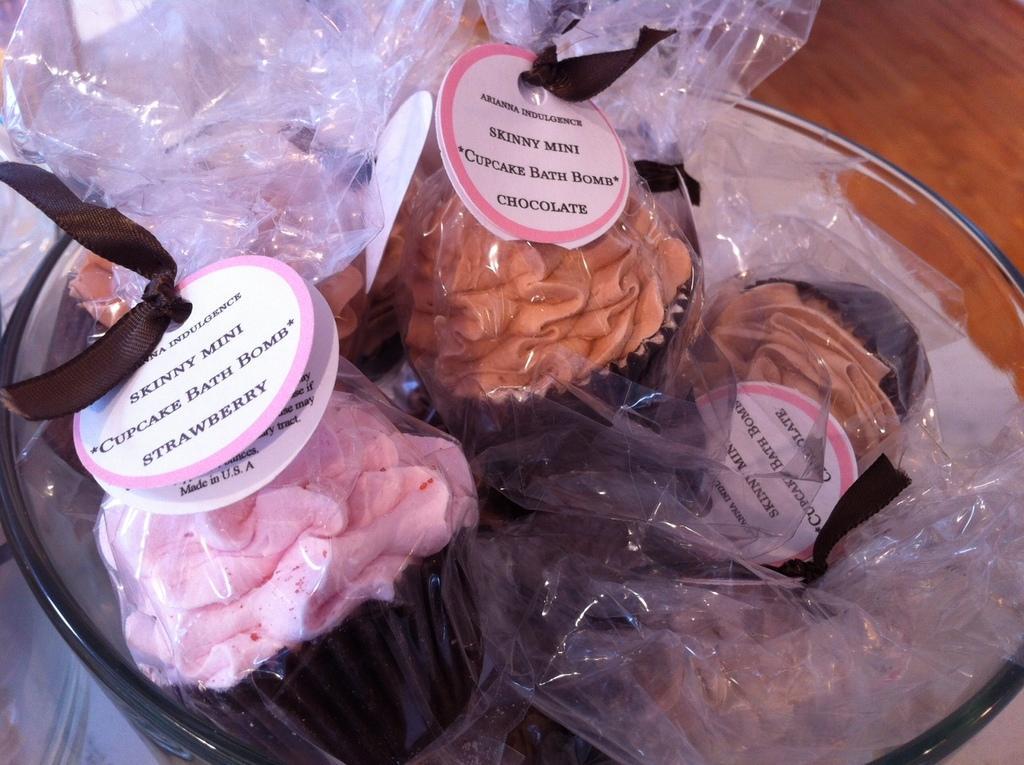Can you describe this image briefly? In this picture we can see food in the plastic bags, and also we can see a bowl. 